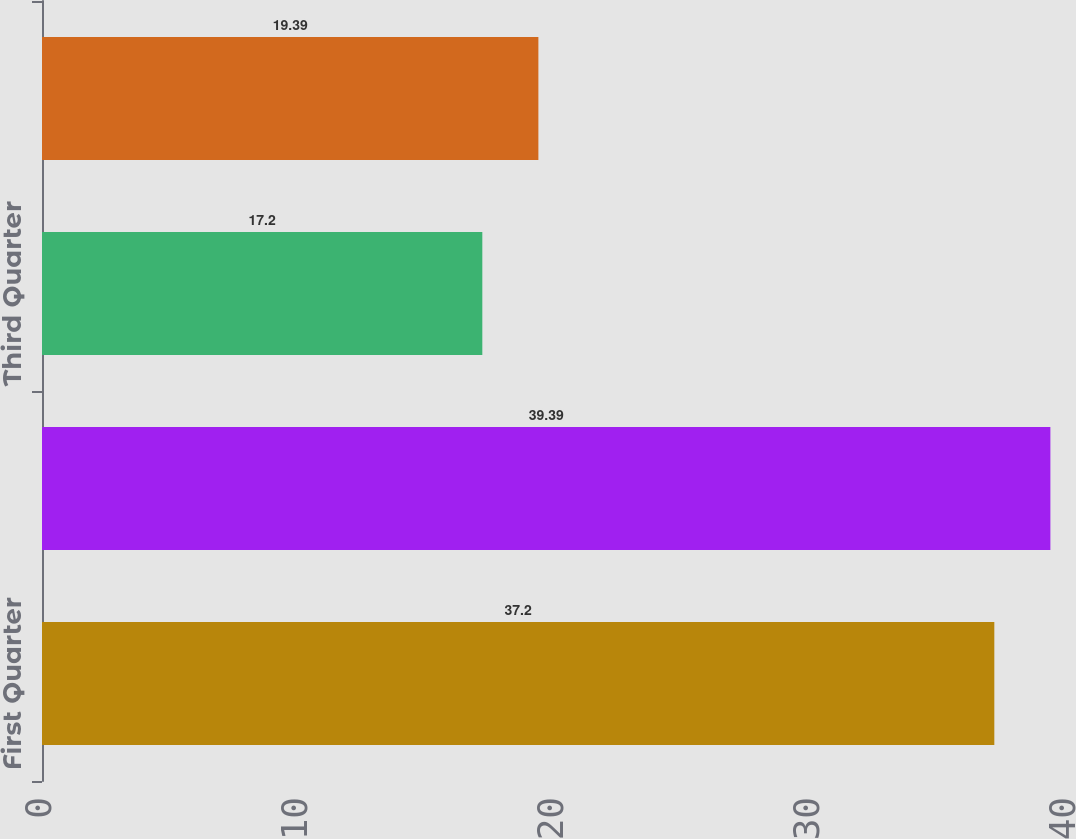Convert chart to OTSL. <chart><loc_0><loc_0><loc_500><loc_500><bar_chart><fcel>First Quarter<fcel>Second Quarter<fcel>Third Quarter<fcel>Fourth Quarter<nl><fcel>37.2<fcel>39.39<fcel>17.2<fcel>19.39<nl></chart> 